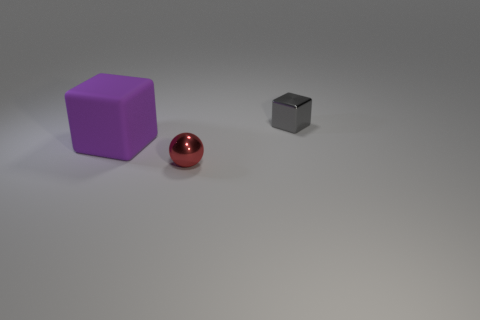Is the number of objects right of the small metallic sphere less than the number of large rubber objects?
Your answer should be compact. No. Do the tiny thing to the left of the shiny block and the tiny cube have the same material?
Offer a terse response. Yes. The ball that is made of the same material as the tiny gray thing is what color?
Your answer should be very brief. Red. Are there fewer red balls on the left side of the large purple cube than tiny gray cubes behind the metal ball?
Your answer should be very brief. Yes. Is there a small ball that has the same material as the gray cube?
Provide a short and direct response. Yes. There is a object to the left of the tiny red metal sphere in front of the tiny shiny cube; what is its size?
Your answer should be very brief. Large. Are there more gray metal cubes than shiny things?
Your answer should be compact. No. Does the cube behind the purple rubber thing have the same size as the sphere?
Provide a succinct answer. Yes. What number of other small metal balls are the same color as the sphere?
Provide a succinct answer. 0. Is the large purple matte object the same shape as the gray object?
Your answer should be very brief. Yes. 